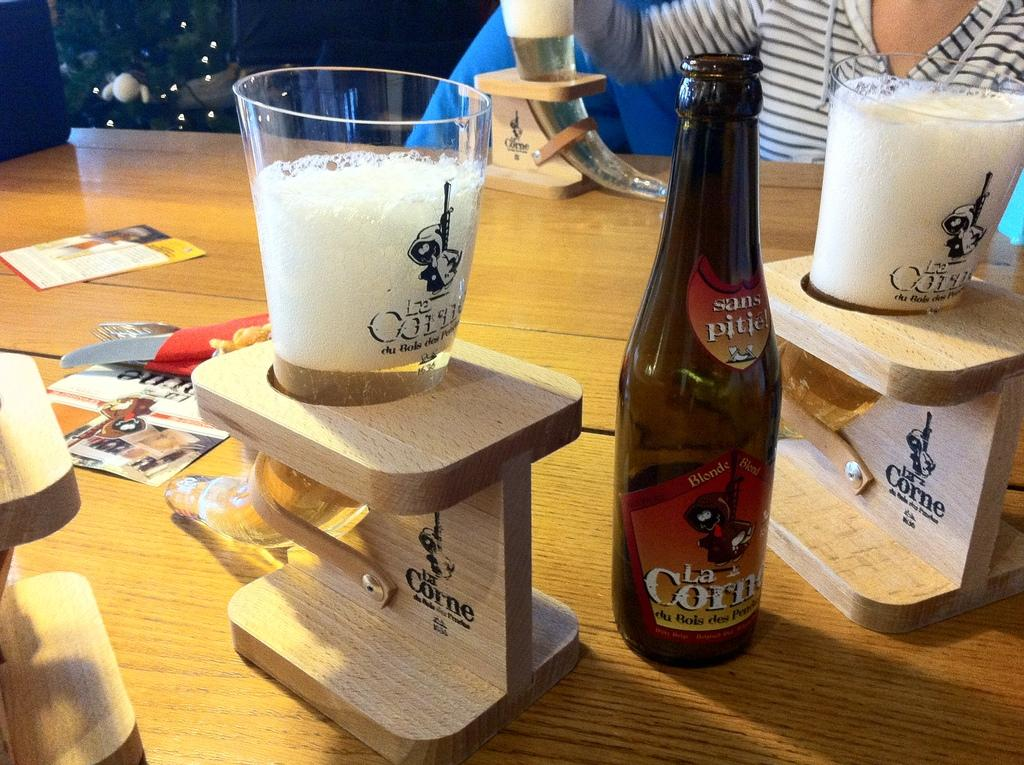<image>
Describe the image concisely. bottle of la corne next to wooden glass holders that have la corne on them as well 